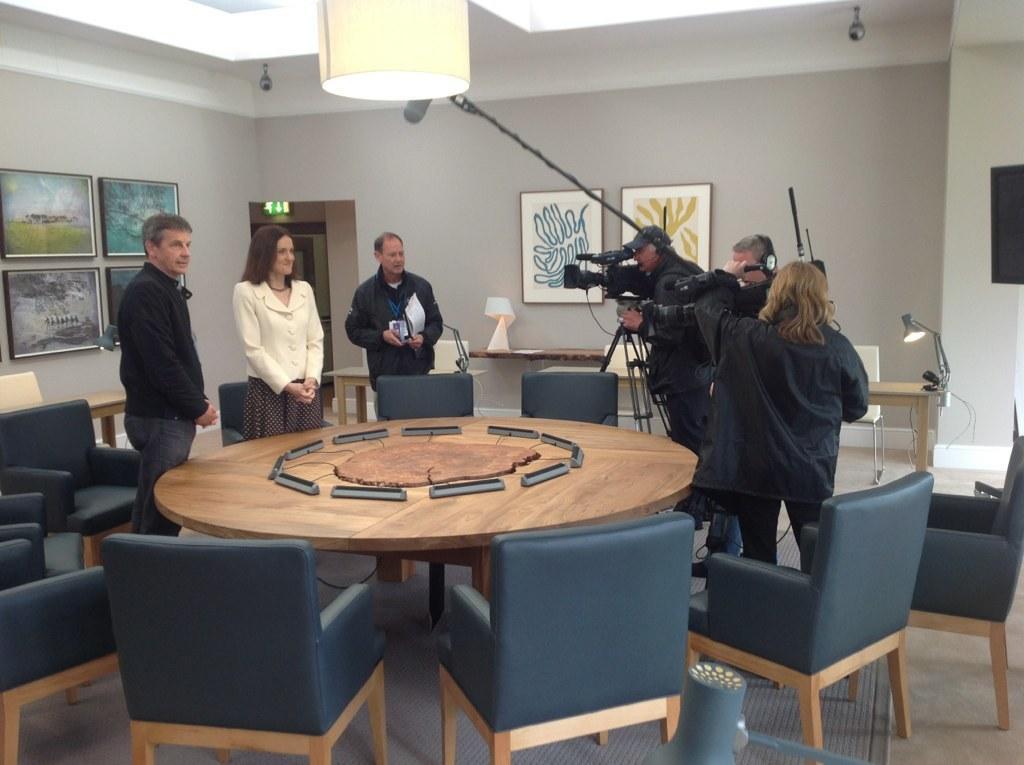Can you describe this image briefly? In this picture there is a table in the center of the image and there are chairs around the table and there are people those who are standing on the left side of the image and there are other people on the right side of the image, they are taking photos and there are tables behind them and there are portraits on the wall and there are cameras and lamp on the roof at the top side of the image. 